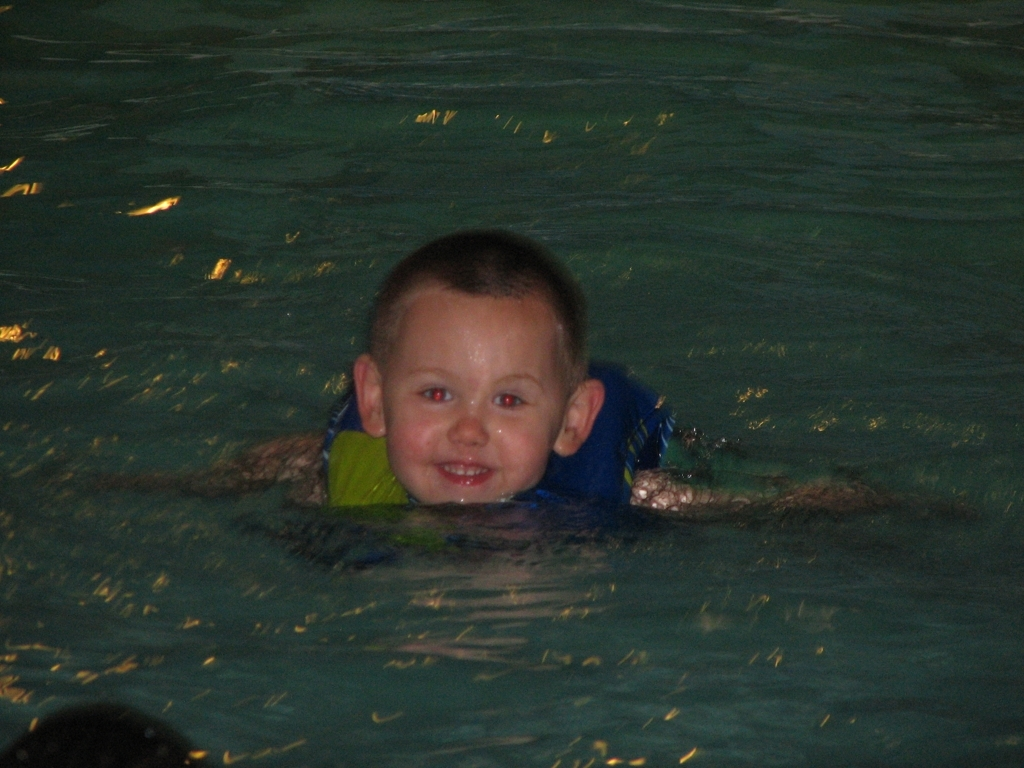What emotions does the child seem to be experiencing? The child appears to be enjoying the water, showing a big smile which reflects happiness and delight. 